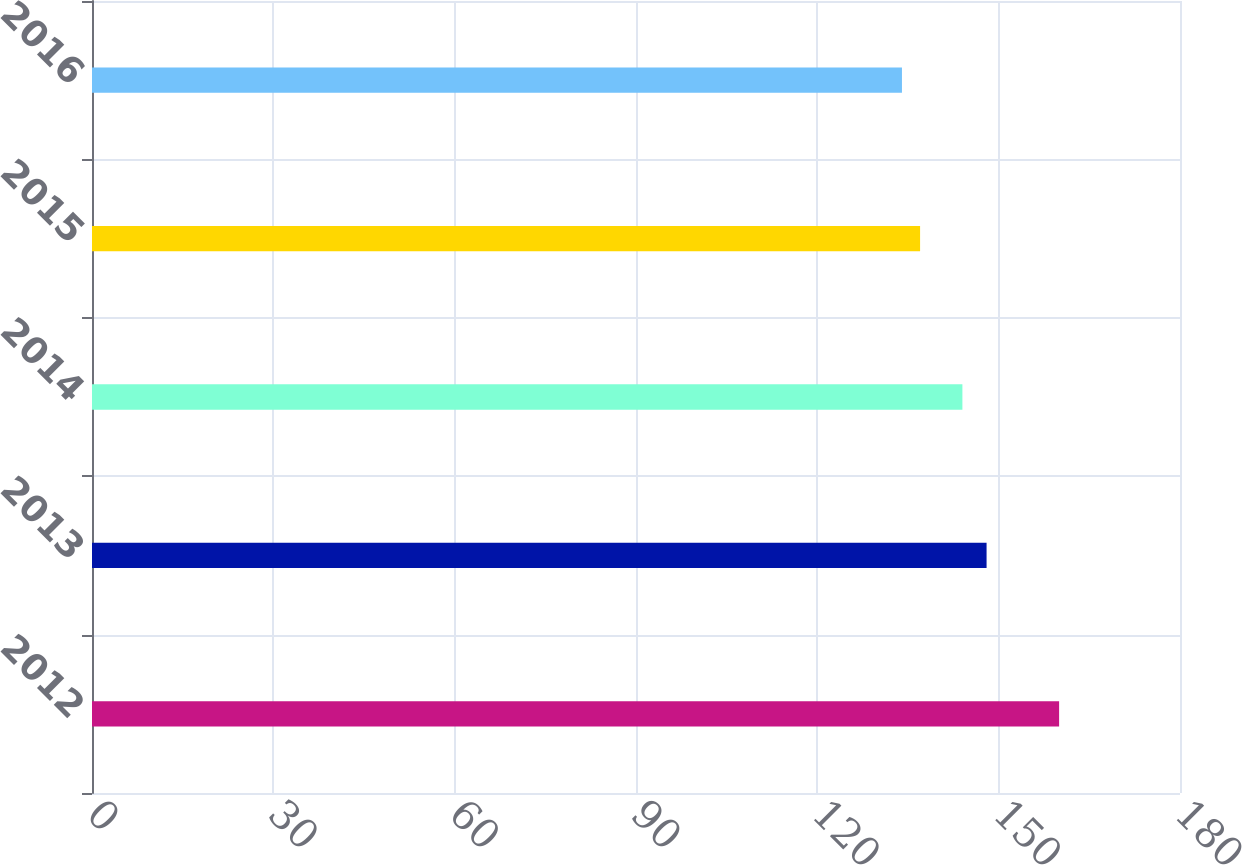Convert chart to OTSL. <chart><loc_0><loc_0><loc_500><loc_500><bar_chart><fcel>2012<fcel>2013<fcel>2014<fcel>2015<fcel>2016<nl><fcel>160<fcel>148<fcel>144<fcel>137<fcel>134<nl></chart> 